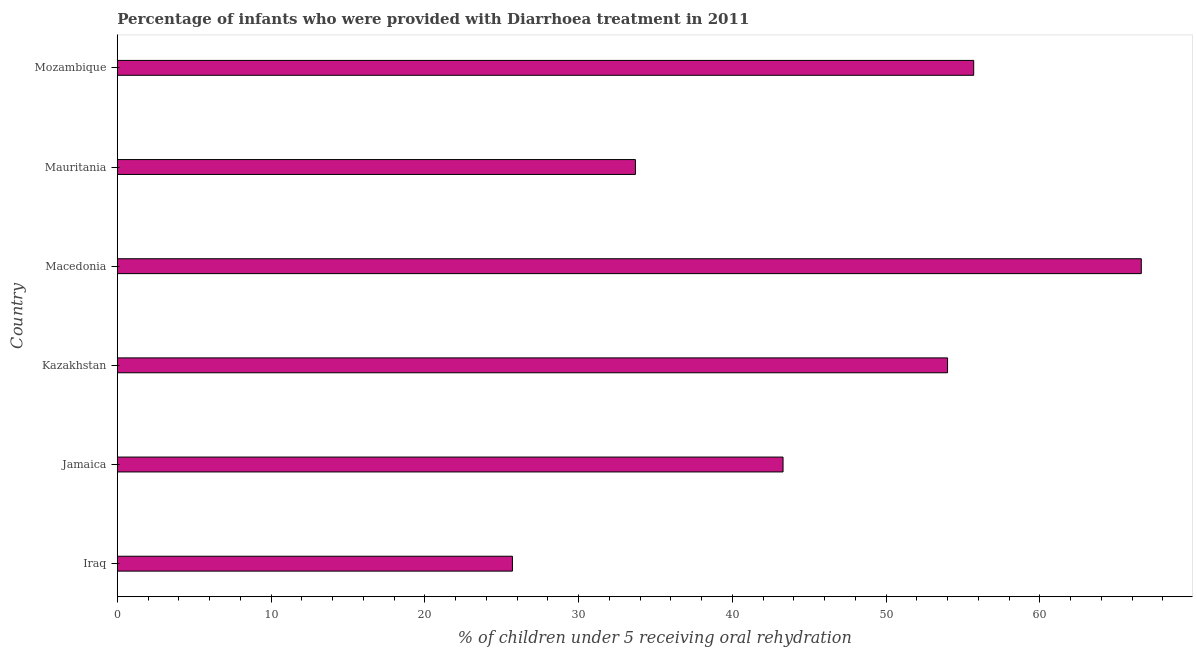Does the graph contain grids?
Provide a short and direct response. No. What is the title of the graph?
Make the answer very short. Percentage of infants who were provided with Diarrhoea treatment in 2011. What is the label or title of the X-axis?
Your answer should be very brief. % of children under 5 receiving oral rehydration. What is the percentage of children who were provided with treatment diarrhoea in Macedonia?
Offer a very short reply. 66.6. Across all countries, what is the maximum percentage of children who were provided with treatment diarrhoea?
Keep it short and to the point. 66.6. Across all countries, what is the minimum percentage of children who were provided with treatment diarrhoea?
Provide a succinct answer. 25.7. In which country was the percentage of children who were provided with treatment diarrhoea maximum?
Keep it short and to the point. Macedonia. In which country was the percentage of children who were provided with treatment diarrhoea minimum?
Ensure brevity in your answer.  Iraq. What is the sum of the percentage of children who were provided with treatment diarrhoea?
Your response must be concise. 279. What is the difference between the percentage of children who were provided with treatment diarrhoea in Iraq and Kazakhstan?
Provide a succinct answer. -28.3. What is the average percentage of children who were provided with treatment diarrhoea per country?
Ensure brevity in your answer.  46.5. What is the median percentage of children who were provided with treatment diarrhoea?
Ensure brevity in your answer.  48.65. What is the ratio of the percentage of children who were provided with treatment diarrhoea in Jamaica to that in Macedonia?
Your answer should be compact. 0.65. Is the percentage of children who were provided with treatment diarrhoea in Iraq less than that in Mozambique?
Offer a very short reply. Yes. Is the difference between the percentage of children who were provided with treatment diarrhoea in Mauritania and Mozambique greater than the difference between any two countries?
Give a very brief answer. No. What is the difference between the highest and the second highest percentage of children who were provided with treatment diarrhoea?
Your answer should be very brief. 10.9. Is the sum of the percentage of children who were provided with treatment diarrhoea in Jamaica and Kazakhstan greater than the maximum percentage of children who were provided with treatment diarrhoea across all countries?
Provide a succinct answer. Yes. What is the difference between the highest and the lowest percentage of children who were provided with treatment diarrhoea?
Your answer should be very brief. 40.9. In how many countries, is the percentage of children who were provided with treatment diarrhoea greater than the average percentage of children who were provided with treatment diarrhoea taken over all countries?
Your response must be concise. 3. How many countries are there in the graph?
Your answer should be compact. 6. What is the % of children under 5 receiving oral rehydration in Iraq?
Provide a short and direct response. 25.7. What is the % of children under 5 receiving oral rehydration in Jamaica?
Ensure brevity in your answer.  43.3. What is the % of children under 5 receiving oral rehydration in Macedonia?
Offer a very short reply. 66.6. What is the % of children under 5 receiving oral rehydration in Mauritania?
Keep it short and to the point. 33.7. What is the % of children under 5 receiving oral rehydration of Mozambique?
Offer a terse response. 55.7. What is the difference between the % of children under 5 receiving oral rehydration in Iraq and Jamaica?
Provide a short and direct response. -17.6. What is the difference between the % of children under 5 receiving oral rehydration in Iraq and Kazakhstan?
Provide a succinct answer. -28.3. What is the difference between the % of children under 5 receiving oral rehydration in Iraq and Macedonia?
Your answer should be compact. -40.9. What is the difference between the % of children under 5 receiving oral rehydration in Iraq and Mauritania?
Provide a succinct answer. -8. What is the difference between the % of children under 5 receiving oral rehydration in Iraq and Mozambique?
Your answer should be very brief. -30. What is the difference between the % of children under 5 receiving oral rehydration in Jamaica and Macedonia?
Offer a very short reply. -23.3. What is the difference between the % of children under 5 receiving oral rehydration in Kazakhstan and Mauritania?
Your answer should be very brief. 20.3. What is the difference between the % of children under 5 receiving oral rehydration in Macedonia and Mauritania?
Your response must be concise. 32.9. What is the difference between the % of children under 5 receiving oral rehydration in Macedonia and Mozambique?
Your answer should be compact. 10.9. What is the ratio of the % of children under 5 receiving oral rehydration in Iraq to that in Jamaica?
Give a very brief answer. 0.59. What is the ratio of the % of children under 5 receiving oral rehydration in Iraq to that in Kazakhstan?
Provide a short and direct response. 0.48. What is the ratio of the % of children under 5 receiving oral rehydration in Iraq to that in Macedonia?
Make the answer very short. 0.39. What is the ratio of the % of children under 5 receiving oral rehydration in Iraq to that in Mauritania?
Your answer should be very brief. 0.76. What is the ratio of the % of children under 5 receiving oral rehydration in Iraq to that in Mozambique?
Keep it short and to the point. 0.46. What is the ratio of the % of children under 5 receiving oral rehydration in Jamaica to that in Kazakhstan?
Your answer should be compact. 0.8. What is the ratio of the % of children under 5 receiving oral rehydration in Jamaica to that in Macedonia?
Provide a succinct answer. 0.65. What is the ratio of the % of children under 5 receiving oral rehydration in Jamaica to that in Mauritania?
Offer a very short reply. 1.28. What is the ratio of the % of children under 5 receiving oral rehydration in Jamaica to that in Mozambique?
Provide a succinct answer. 0.78. What is the ratio of the % of children under 5 receiving oral rehydration in Kazakhstan to that in Macedonia?
Provide a succinct answer. 0.81. What is the ratio of the % of children under 5 receiving oral rehydration in Kazakhstan to that in Mauritania?
Your answer should be compact. 1.6. What is the ratio of the % of children under 5 receiving oral rehydration in Macedonia to that in Mauritania?
Provide a succinct answer. 1.98. What is the ratio of the % of children under 5 receiving oral rehydration in Macedonia to that in Mozambique?
Your response must be concise. 1.2. What is the ratio of the % of children under 5 receiving oral rehydration in Mauritania to that in Mozambique?
Your answer should be compact. 0.6. 